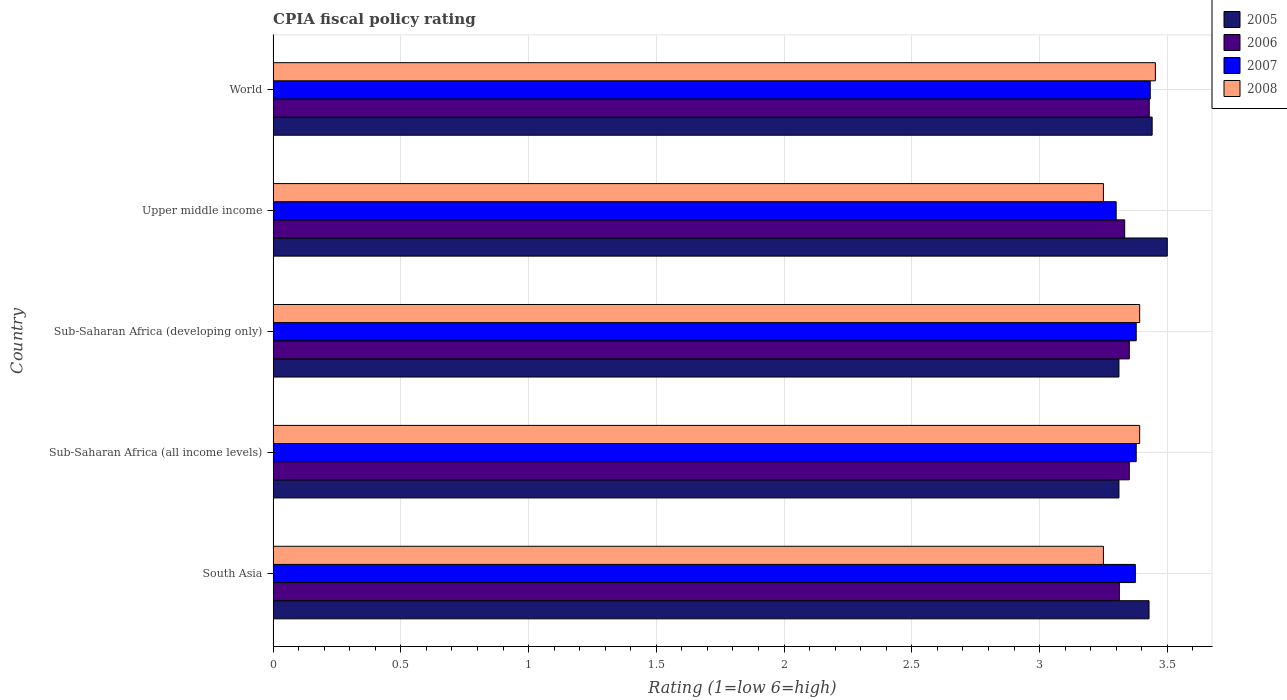How many bars are there on the 2nd tick from the top?
Provide a short and direct response. 4. What is the label of the 3rd group of bars from the top?
Keep it short and to the point. Sub-Saharan Africa (developing only). In how many cases, is the number of bars for a given country not equal to the number of legend labels?
Offer a terse response. 0. What is the CPIA rating in 2005 in Sub-Saharan Africa (developing only)?
Your response must be concise. 3.31. Across all countries, what is the maximum CPIA rating in 2006?
Provide a succinct answer. 3.43. Across all countries, what is the minimum CPIA rating in 2007?
Your answer should be compact. 3.3. What is the total CPIA rating in 2006 in the graph?
Keep it short and to the point. 16.78. What is the difference between the CPIA rating in 2007 in Sub-Saharan Africa (developing only) and that in Upper middle income?
Offer a terse response. 0.08. What is the difference between the CPIA rating in 2008 in Sub-Saharan Africa (developing only) and the CPIA rating in 2005 in World?
Your response must be concise. -0.05. What is the average CPIA rating in 2005 per country?
Your response must be concise. 3.4. What is the difference between the CPIA rating in 2005 and CPIA rating in 2008 in Sub-Saharan Africa (developing only)?
Ensure brevity in your answer.  -0.08. In how many countries, is the CPIA rating in 2008 greater than 0.4 ?
Ensure brevity in your answer.  5. What is the ratio of the CPIA rating in 2007 in Upper middle income to that in World?
Keep it short and to the point. 0.96. What is the difference between the highest and the second highest CPIA rating in 2005?
Make the answer very short. 0.06. What is the difference between the highest and the lowest CPIA rating in 2007?
Your response must be concise. 0.13. In how many countries, is the CPIA rating in 2005 greater than the average CPIA rating in 2005 taken over all countries?
Provide a succinct answer. 3. What does the 1st bar from the top in Upper middle income represents?
Your response must be concise. 2008. Is it the case that in every country, the sum of the CPIA rating in 2007 and CPIA rating in 2006 is greater than the CPIA rating in 2005?
Keep it short and to the point. Yes. Are all the bars in the graph horizontal?
Ensure brevity in your answer.  Yes. How many countries are there in the graph?
Offer a terse response. 5. Does the graph contain any zero values?
Keep it short and to the point. No. Does the graph contain grids?
Your answer should be compact. Yes. Where does the legend appear in the graph?
Your answer should be compact. Top right. How many legend labels are there?
Provide a succinct answer. 4. How are the legend labels stacked?
Give a very brief answer. Vertical. What is the title of the graph?
Provide a succinct answer. CPIA fiscal policy rating. What is the Rating (1=low 6=high) of 2005 in South Asia?
Provide a succinct answer. 3.43. What is the Rating (1=low 6=high) in 2006 in South Asia?
Ensure brevity in your answer.  3.31. What is the Rating (1=low 6=high) in 2007 in South Asia?
Offer a very short reply. 3.38. What is the Rating (1=low 6=high) of 2008 in South Asia?
Offer a very short reply. 3.25. What is the Rating (1=low 6=high) in 2005 in Sub-Saharan Africa (all income levels)?
Make the answer very short. 3.31. What is the Rating (1=low 6=high) of 2006 in Sub-Saharan Africa (all income levels)?
Your answer should be compact. 3.35. What is the Rating (1=low 6=high) of 2007 in Sub-Saharan Africa (all income levels)?
Offer a very short reply. 3.38. What is the Rating (1=low 6=high) of 2008 in Sub-Saharan Africa (all income levels)?
Your response must be concise. 3.39. What is the Rating (1=low 6=high) of 2005 in Sub-Saharan Africa (developing only)?
Offer a terse response. 3.31. What is the Rating (1=low 6=high) in 2006 in Sub-Saharan Africa (developing only)?
Keep it short and to the point. 3.35. What is the Rating (1=low 6=high) in 2007 in Sub-Saharan Africa (developing only)?
Offer a very short reply. 3.38. What is the Rating (1=low 6=high) of 2008 in Sub-Saharan Africa (developing only)?
Provide a short and direct response. 3.39. What is the Rating (1=low 6=high) of 2005 in Upper middle income?
Offer a very short reply. 3.5. What is the Rating (1=low 6=high) in 2006 in Upper middle income?
Give a very brief answer. 3.33. What is the Rating (1=low 6=high) of 2007 in Upper middle income?
Your answer should be compact. 3.3. What is the Rating (1=low 6=high) in 2005 in World?
Give a very brief answer. 3.44. What is the Rating (1=low 6=high) of 2006 in World?
Your answer should be very brief. 3.43. What is the Rating (1=low 6=high) in 2007 in World?
Your answer should be compact. 3.43. What is the Rating (1=low 6=high) in 2008 in World?
Give a very brief answer. 3.45. Across all countries, what is the maximum Rating (1=low 6=high) in 2005?
Give a very brief answer. 3.5. Across all countries, what is the maximum Rating (1=low 6=high) in 2006?
Your answer should be very brief. 3.43. Across all countries, what is the maximum Rating (1=low 6=high) of 2007?
Give a very brief answer. 3.43. Across all countries, what is the maximum Rating (1=low 6=high) in 2008?
Your answer should be very brief. 3.45. Across all countries, what is the minimum Rating (1=low 6=high) of 2005?
Offer a very short reply. 3.31. Across all countries, what is the minimum Rating (1=low 6=high) of 2006?
Keep it short and to the point. 3.31. What is the total Rating (1=low 6=high) of 2005 in the graph?
Your response must be concise. 16.99. What is the total Rating (1=low 6=high) in 2006 in the graph?
Give a very brief answer. 16.78. What is the total Rating (1=low 6=high) in 2007 in the graph?
Offer a very short reply. 16.87. What is the total Rating (1=low 6=high) in 2008 in the graph?
Ensure brevity in your answer.  16.74. What is the difference between the Rating (1=low 6=high) in 2005 in South Asia and that in Sub-Saharan Africa (all income levels)?
Provide a short and direct response. 0.12. What is the difference between the Rating (1=low 6=high) in 2006 in South Asia and that in Sub-Saharan Africa (all income levels)?
Provide a short and direct response. -0.04. What is the difference between the Rating (1=low 6=high) in 2007 in South Asia and that in Sub-Saharan Africa (all income levels)?
Keep it short and to the point. -0. What is the difference between the Rating (1=low 6=high) in 2008 in South Asia and that in Sub-Saharan Africa (all income levels)?
Ensure brevity in your answer.  -0.14. What is the difference between the Rating (1=low 6=high) in 2005 in South Asia and that in Sub-Saharan Africa (developing only)?
Offer a very short reply. 0.12. What is the difference between the Rating (1=low 6=high) of 2006 in South Asia and that in Sub-Saharan Africa (developing only)?
Ensure brevity in your answer.  -0.04. What is the difference between the Rating (1=low 6=high) in 2007 in South Asia and that in Sub-Saharan Africa (developing only)?
Provide a succinct answer. -0. What is the difference between the Rating (1=low 6=high) in 2008 in South Asia and that in Sub-Saharan Africa (developing only)?
Give a very brief answer. -0.14. What is the difference between the Rating (1=low 6=high) of 2005 in South Asia and that in Upper middle income?
Provide a short and direct response. -0.07. What is the difference between the Rating (1=low 6=high) of 2006 in South Asia and that in Upper middle income?
Offer a terse response. -0.02. What is the difference between the Rating (1=low 6=high) of 2007 in South Asia and that in Upper middle income?
Provide a short and direct response. 0.07. What is the difference between the Rating (1=low 6=high) in 2008 in South Asia and that in Upper middle income?
Ensure brevity in your answer.  0. What is the difference between the Rating (1=low 6=high) of 2005 in South Asia and that in World?
Offer a very short reply. -0.01. What is the difference between the Rating (1=low 6=high) in 2006 in South Asia and that in World?
Make the answer very short. -0.12. What is the difference between the Rating (1=low 6=high) in 2007 in South Asia and that in World?
Ensure brevity in your answer.  -0.06. What is the difference between the Rating (1=low 6=high) of 2008 in South Asia and that in World?
Make the answer very short. -0.2. What is the difference between the Rating (1=low 6=high) in 2005 in Sub-Saharan Africa (all income levels) and that in Upper middle income?
Your answer should be very brief. -0.19. What is the difference between the Rating (1=low 6=high) of 2006 in Sub-Saharan Africa (all income levels) and that in Upper middle income?
Make the answer very short. 0.02. What is the difference between the Rating (1=low 6=high) of 2007 in Sub-Saharan Africa (all income levels) and that in Upper middle income?
Your answer should be very brief. 0.08. What is the difference between the Rating (1=low 6=high) in 2008 in Sub-Saharan Africa (all income levels) and that in Upper middle income?
Make the answer very short. 0.14. What is the difference between the Rating (1=low 6=high) of 2005 in Sub-Saharan Africa (all income levels) and that in World?
Offer a very short reply. -0.13. What is the difference between the Rating (1=low 6=high) in 2006 in Sub-Saharan Africa (all income levels) and that in World?
Offer a terse response. -0.08. What is the difference between the Rating (1=low 6=high) in 2007 in Sub-Saharan Africa (all income levels) and that in World?
Your response must be concise. -0.06. What is the difference between the Rating (1=low 6=high) of 2008 in Sub-Saharan Africa (all income levels) and that in World?
Offer a very short reply. -0.06. What is the difference between the Rating (1=low 6=high) in 2005 in Sub-Saharan Africa (developing only) and that in Upper middle income?
Your answer should be compact. -0.19. What is the difference between the Rating (1=low 6=high) in 2006 in Sub-Saharan Africa (developing only) and that in Upper middle income?
Provide a short and direct response. 0.02. What is the difference between the Rating (1=low 6=high) of 2007 in Sub-Saharan Africa (developing only) and that in Upper middle income?
Offer a very short reply. 0.08. What is the difference between the Rating (1=low 6=high) in 2008 in Sub-Saharan Africa (developing only) and that in Upper middle income?
Keep it short and to the point. 0.14. What is the difference between the Rating (1=low 6=high) of 2005 in Sub-Saharan Africa (developing only) and that in World?
Ensure brevity in your answer.  -0.13. What is the difference between the Rating (1=low 6=high) in 2006 in Sub-Saharan Africa (developing only) and that in World?
Ensure brevity in your answer.  -0.08. What is the difference between the Rating (1=low 6=high) in 2007 in Sub-Saharan Africa (developing only) and that in World?
Keep it short and to the point. -0.06. What is the difference between the Rating (1=low 6=high) in 2008 in Sub-Saharan Africa (developing only) and that in World?
Your answer should be very brief. -0.06. What is the difference between the Rating (1=low 6=high) of 2005 in Upper middle income and that in World?
Provide a short and direct response. 0.06. What is the difference between the Rating (1=low 6=high) of 2006 in Upper middle income and that in World?
Offer a terse response. -0.1. What is the difference between the Rating (1=low 6=high) in 2007 in Upper middle income and that in World?
Your response must be concise. -0.13. What is the difference between the Rating (1=low 6=high) of 2008 in Upper middle income and that in World?
Give a very brief answer. -0.2. What is the difference between the Rating (1=low 6=high) in 2005 in South Asia and the Rating (1=low 6=high) in 2006 in Sub-Saharan Africa (all income levels)?
Your response must be concise. 0.08. What is the difference between the Rating (1=low 6=high) in 2005 in South Asia and the Rating (1=low 6=high) in 2007 in Sub-Saharan Africa (all income levels)?
Your answer should be very brief. 0.05. What is the difference between the Rating (1=low 6=high) in 2005 in South Asia and the Rating (1=low 6=high) in 2008 in Sub-Saharan Africa (all income levels)?
Your response must be concise. 0.04. What is the difference between the Rating (1=low 6=high) of 2006 in South Asia and the Rating (1=low 6=high) of 2007 in Sub-Saharan Africa (all income levels)?
Make the answer very short. -0.07. What is the difference between the Rating (1=low 6=high) of 2006 in South Asia and the Rating (1=low 6=high) of 2008 in Sub-Saharan Africa (all income levels)?
Your response must be concise. -0.08. What is the difference between the Rating (1=low 6=high) of 2007 in South Asia and the Rating (1=low 6=high) of 2008 in Sub-Saharan Africa (all income levels)?
Provide a succinct answer. -0.02. What is the difference between the Rating (1=low 6=high) in 2005 in South Asia and the Rating (1=low 6=high) in 2006 in Sub-Saharan Africa (developing only)?
Keep it short and to the point. 0.08. What is the difference between the Rating (1=low 6=high) of 2005 in South Asia and the Rating (1=low 6=high) of 2007 in Sub-Saharan Africa (developing only)?
Provide a short and direct response. 0.05. What is the difference between the Rating (1=low 6=high) in 2005 in South Asia and the Rating (1=low 6=high) in 2008 in Sub-Saharan Africa (developing only)?
Your response must be concise. 0.04. What is the difference between the Rating (1=low 6=high) of 2006 in South Asia and the Rating (1=low 6=high) of 2007 in Sub-Saharan Africa (developing only)?
Your answer should be very brief. -0.07. What is the difference between the Rating (1=low 6=high) in 2006 in South Asia and the Rating (1=low 6=high) in 2008 in Sub-Saharan Africa (developing only)?
Offer a very short reply. -0.08. What is the difference between the Rating (1=low 6=high) in 2007 in South Asia and the Rating (1=low 6=high) in 2008 in Sub-Saharan Africa (developing only)?
Offer a very short reply. -0.02. What is the difference between the Rating (1=low 6=high) in 2005 in South Asia and the Rating (1=low 6=high) in 2006 in Upper middle income?
Give a very brief answer. 0.1. What is the difference between the Rating (1=low 6=high) of 2005 in South Asia and the Rating (1=low 6=high) of 2007 in Upper middle income?
Offer a terse response. 0.13. What is the difference between the Rating (1=low 6=high) in 2005 in South Asia and the Rating (1=low 6=high) in 2008 in Upper middle income?
Provide a short and direct response. 0.18. What is the difference between the Rating (1=low 6=high) in 2006 in South Asia and the Rating (1=low 6=high) in 2007 in Upper middle income?
Offer a very short reply. 0.01. What is the difference between the Rating (1=low 6=high) in 2006 in South Asia and the Rating (1=low 6=high) in 2008 in Upper middle income?
Your answer should be very brief. 0.06. What is the difference between the Rating (1=low 6=high) in 2007 in South Asia and the Rating (1=low 6=high) in 2008 in Upper middle income?
Keep it short and to the point. 0.12. What is the difference between the Rating (1=low 6=high) in 2005 in South Asia and the Rating (1=low 6=high) in 2006 in World?
Your response must be concise. -0. What is the difference between the Rating (1=low 6=high) in 2005 in South Asia and the Rating (1=low 6=high) in 2007 in World?
Offer a very short reply. -0. What is the difference between the Rating (1=low 6=high) in 2005 in South Asia and the Rating (1=low 6=high) in 2008 in World?
Keep it short and to the point. -0.02. What is the difference between the Rating (1=low 6=high) of 2006 in South Asia and the Rating (1=low 6=high) of 2007 in World?
Provide a short and direct response. -0.12. What is the difference between the Rating (1=low 6=high) in 2006 in South Asia and the Rating (1=low 6=high) in 2008 in World?
Offer a terse response. -0.14. What is the difference between the Rating (1=low 6=high) in 2007 in South Asia and the Rating (1=low 6=high) in 2008 in World?
Offer a terse response. -0.08. What is the difference between the Rating (1=low 6=high) of 2005 in Sub-Saharan Africa (all income levels) and the Rating (1=low 6=high) of 2006 in Sub-Saharan Africa (developing only)?
Ensure brevity in your answer.  -0.04. What is the difference between the Rating (1=low 6=high) in 2005 in Sub-Saharan Africa (all income levels) and the Rating (1=low 6=high) in 2007 in Sub-Saharan Africa (developing only)?
Provide a short and direct response. -0.07. What is the difference between the Rating (1=low 6=high) of 2005 in Sub-Saharan Africa (all income levels) and the Rating (1=low 6=high) of 2008 in Sub-Saharan Africa (developing only)?
Offer a very short reply. -0.08. What is the difference between the Rating (1=low 6=high) of 2006 in Sub-Saharan Africa (all income levels) and the Rating (1=low 6=high) of 2007 in Sub-Saharan Africa (developing only)?
Offer a terse response. -0.03. What is the difference between the Rating (1=low 6=high) in 2006 in Sub-Saharan Africa (all income levels) and the Rating (1=low 6=high) in 2008 in Sub-Saharan Africa (developing only)?
Your response must be concise. -0.04. What is the difference between the Rating (1=low 6=high) in 2007 in Sub-Saharan Africa (all income levels) and the Rating (1=low 6=high) in 2008 in Sub-Saharan Africa (developing only)?
Keep it short and to the point. -0.01. What is the difference between the Rating (1=low 6=high) of 2005 in Sub-Saharan Africa (all income levels) and the Rating (1=low 6=high) of 2006 in Upper middle income?
Offer a terse response. -0.02. What is the difference between the Rating (1=low 6=high) in 2005 in Sub-Saharan Africa (all income levels) and the Rating (1=low 6=high) in 2007 in Upper middle income?
Make the answer very short. 0.01. What is the difference between the Rating (1=low 6=high) in 2005 in Sub-Saharan Africa (all income levels) and the Rating (1=low 6=high) in 2008 in Upper middle income?
Provide a short and direct response. 0.06. What is the difference between the Rating (1=low 6=high) in 2006 in Sub-Saharan Africa (all income levels) and the Rating (1=low 6=high) in 2007 in Upper middle income?
Keep it short and to the point. 0.05. What is the difference between the Rating (1=low 6=high) of 2006 in Sub-Saharan Africa (all income levels) and the Rating (1=low 6=high) of 2008 in Upper middle income?
Your answer should be compact. 0.1. What is the difference between the Rating (1=low 6=high) of 2007 in Sub-Saharan Africa (all income levels) and the Rating (1=low 6=high) of 2008 in Upper middle income?
Keep it short and to the point. 0.13. What is the difference between the Rating (1=low 6=high) in 2005 in Sub-Saharan Africa (all income levels) and the Rating (1=low 6=high) in 2006 in World?
Give a very brief answer. -0.12. What is the difference between the Rating (1=low 6=high) of 2005 in Sub-Saharan Africa (all income levels) and the Rating (1=low 6=high) of 2007 in World?
Ensure brevity in your answer.  -0.12. What is the difference between the Rating (1=low 6=high) of 2005 in Sub-Saharan Africa (all income levels) and the Rating (1=low 6=high) of 2008 in World?
Offer a very short reply. -0.14. What is the difference between the Rating (1=low 6=high) in 2006 in Sub-Saharan Africa (all income levels) and the Rating (1=low 6=high) in 2007 in World?
Make the answer very short. -0.08. What is the difference between the Rating (1=low 6=high) in 2006 in Sub-Saharan Africa (all income levels) and the Rating (1=low 6=high) in 2008 in World?
Provide a short and direct response. -0.1. What is the difference between the Rating (1=low 6=high) of 2007 in Sub-Saharan Africa (all income levels) and the Rating (1=low 6=high) of 2008 in World?
Provide a short and direct response. -0.07. What is the difference between the Rating (1=low 6=high) of 2005 in Sub-Saharan Africa (developing only) and the Rating (1=low 6=high) of 2006 in Upper middle income?
Keep it short and to the point. -0.02. What is the difference between the Rating (1=low 6=high) in 2005 in Sub-Saharan Africa (developing only) and the Rating (1=low 6=high) in 2007 in Upper middle income?
Ensure brevity in your answer.  0.01. What is the difference between the Rating (1=low 6=high) in 2005 in Sub-Saharan Africa (developing only) and the Rating (1=low 6=high) in 2008 in Upper middle income?
Offer a very short reply. 0.06. What is the difference between the Rating (1=low 6=high) of 2006 in Sub-Saharan Africa (developing only) and the Rating (1=low 6=high) of 2007 in Upper middle income?
Offer a very short reply. 0.05. What is the difference between the Rating (1=low 6=high) in 2006 in Sub-Saharan Africa (developing only) and the Rating (1=low 6=high) in 2008 in Upper middle income?
Offer a very short reply. 0.1. What is the difference between the Rating (1=low 6=high) in 2007 in Sub-Saharan Africa (developing only) and the Rating (1=low 6=high) in 2008 in Upper middle income?
Your answer should be very brief. 0.13. What is the difference between the Rating (1=low 6=high) in 2005 in Sub-Saharan Africa (developing only) and the Rating (1=low 6=high) in 2006 in World?
Give a very brief answer. -0.12. What is the difference between the Rating (1=low 6=high) of 2005 in Sub-Saharan Africa (developing only) and the Rating (1=low 6=high) of 2007 in World?
Your answer should be very brief. -0.12. What is the difference between the Rating (1=low 6=high) in 2005 in Sub-Saharan Africa (developing only) and the Rating (1=low 6=high) in 2008 in World?
Provide a short and direct response. -0.14. What is the difference between the Rating (1=low 6=high) in 2006 in Sub-Saharan Africa (developing only) and the Rating (1=low 6=high) in 2007 in World?
Offer a terse response. -0.08. What is the difference between the Rating (1=low 6=high) of 2006 in Sub-Saharan Africa (developing only) and the Rating (1=low 6=high) of 2008 in World?
Provide a short and direct response. -0.1. What is the difference between the Rating (1=low 6=high) in 2007 in Sub-Saharan Africa (developing only) and the Rating (1=low 6=high) in 2008 in World?
Provide a succinct answer. -0.07. What is the difference between the Rating (1=low 6=high) of 2005 in Upper middle income and the Rating (1=low 6=high) of 2006 in World?
Provide a short and direct response. 0.07. What is the difference between the Rating (1=low 6=high) of 2005 in Upper middle income and the Rating (1=low 6=high) of 2007 in World?
Your response must be concise. 0.07. What is the difference between the Rating (1=low 6=high) in 2005 in Upper middle income and the Rating (1=low 6=high) in 2008 in World?
Provide a succinct answer. 0.05. What is the difference between the Rating (1=low 6=high) of 2006 in Upper middle income and the Rating (1=low 6=high) of 2007 in World?
Your response must be concise. -0.1. What is the difference between the Rating (1=low 6=high) of 2006 in Upper middle income and the Rating (1=low 6=high) of 2008 in World?
Offer a terse response. -0.12. What is the difference between the Rating (1=low 6=high) in 2007 in Upper middle income and the Rating (1=low 6=high) in 2008 in World?
Offer a very short reply. -0.15. What is the average Rating (1=low 6=high) of 2005 per country?
Offer a terse response. 3.4. What is the average Rating (1=low 6=high) of 2006 per country?
Give a very brief answer. 3.36. What is the average Rating (1=low 6=high) of 2007 per country?
Offer a very short reply. 3.37. What is the average Rating (1=low 6=high) of 2008 per country?
Ensure brevity in your answer.  3.35. What is the difference between the Rating (1=low 6=high) in 2005 and Rating (1=low 6=high) in 2006 in South Asia?
Give a very brief answer. 0.12. What is the difference between the Rating (1=low 6=high) of 2005 and Rating (1=low 6=high) of 2007 in South Asia?
Provide a short and direct response. 0.05. What is the difference between the Rating (1=low 6=high) of 2005 and Rating (1=low 6=high) of 2008 in South Asia?
Your response must be concise. 0.18. What is the difference between the Rating (1=low 6=high) in 2006 and Rating (1=low 6=high) in 2007 in South Asia?
Your response must be concise. -0.06. What is the difference between the Rating (1=low 6=high) in 2006 and Rating (1=low 6=high) in 2008 in South Asia?
Give a very brief answer. 0.06. What is the difference between the Rating (1=low 6=high) of 2007 and Rating (1=low 6=high) of 2008 in South Asia?
Your answer should be very brief. 0.12. What is the difference between the Rating (1=low 6=high) of 2005 and Rating (1=low 6=high) of 2006 in Sub-Saharan Africa (all income levels)?
Give a very brief answer. -0.04. What is the difference between the Rating (1=low 6=high) in 2005 and Rating (1=low 6=high) in 2007 in Sub-Saharan Africa (all income levels)?
Offer a terse response. -0.07. What is the difference between the Rating (1=low 6=high) in 2005 and Rating (1=low 6=high) in 2008 in Sub-Saharan Africa (all income levels)?
Offer a very short reply. -0.08. What is the difference between the Rating (1=low 6=high) of 2006 and Rating (1=low 6=high) of 2007 in Sub-Saharan Africa (all income levels)?
Provide a succinct answer. -0.03. What is the difference between the Rating (1=low 6=high) of 2006 and Rating (1=low 6=high) of 2008 in Sub-Saharan Africa (all income levels)?
Give a very brief answer. -0.04. What is the difference between the Rating (1=low 6=high) in 2007 and Rating (1=low 6=high) in 2008 in Sub-Saharan Africa (all income levels)?
Provide a succinct answer. -0.01. What is the difference between the Rating (1=low 6=high) in 2005 and Rating (1=low 6=high) in 2006 in Sub-Saharan Africa (developing only)?
Your answer should be compact. -0.04. What is the difference between the Rating (1=low 6=high) of 2005 and Rating (1=low 6=high) of 2007 in Sub-Saharan Africa (developing only)?
Give a very brief answer. -0.07. What is the difference between the Rating (1=low 6=high) of 2005 and Rating (1=low 6=high) of 2008 in Sub-Saharan Africa (developing only)?
Offer a terse response. -0.08. What is the difference between the Rating (1=low 6=high) in 2006 and Rating (1=low 6=high) in 2007 in Sub-Saharan Africa (developing only)?
Provide a short and direct response. -0.03. What is the difference between the Rating (1=low 6=high) in 2006 and Rating (1=low 6=high) in 2008 in Sub-Saharan Africa (developing only)?
Make the answer very short. -0.04. What is the difference between the Rating (1=low 6=high) of 2007 and Rating (1=low 6=high) of 2008 in Sub-Saharan Africa (developing only)?
Offer a very short reply. -0.01. What is the difference between the Rating (1=low 6=high) in 2005 and Rating (1=low 6=high) in 2008 in Upper middle income?
Keep it short and to the point. 0.25. What is the difference between the Rating (1=low 6=high) in 2006 and Rating (1=low 6=high) in 2008 in Upper middle income?
Make the answer very short. 0.08. What is the difference between the Rating (1=low 6=high) of 2007 and Rating (1=low 6=high) of 2008 in Upper middle income?
Your answer should be compact. 0.05. What is the difference between the Rating (1=low 6=high) of 2005 and Rating (1=low 6=high) of 2006 in World?
Offer a terse response. 0.01. What is the difference between the Rating (1=low 6=high) of 2005 and Rating (1=low 6=high) of 2007 in World?
Ensure brevity in your answer.  0.01. What is the difference between the Rating (1=low 6=high) in 2005 and Rating (1=low 6=high) in 2008 in World?
Ensure brevity in your answer.  -0.01. What is the difference between the Rating (1=low 6=high) of 2006 and Rating (1=low 6=high) of 2007 in World?
Make the answer very short. -0. What is the difference between the Rating (1=low 6=high) of 2006 and Rating (1=low 6=high) of 2008 in World?
Keep it short and to the point. -0.02. What is the difference between the Rating (1=low 6=high) of 2007 and Rating (1=low 6=high) of 2008 in World?
Provide a succinct answer. -0.02. What is the ratio of the Rating (1=low 6=high) of 2005 in South Asia to that in Sub-Saharan Africa (all income levels)?
Your answer should be very brief. 1.04. What is the ratio of the Rating (1=low 6=high) of 2006 in South Asia to that in Sub-Saharan Africa (all income levels)?
Offer a terse response. 0.99. What is the ratio of the Rating (1=low 6=high) in 2007 in South Asia to that in Sub-Saharan Africa (all income levels)?
Give a very brief answer. 1. What is the ratio of the Rating (1=low 6=high) in 2008 in South Asia to that in Sub-Saharan Africa (all income levels)?
Give a very brief answer. 0.96. What is the ratio of the Rating (1=low 6=high) of 2005 in South Asia to that in Sub-Saharan Africa (developing only)?
Your answer should be very brief. 1.04. What is the ratio of the Rating (1=low 6=high) of 2006 in South Asia to that in Sub-Saharan Africa (developing only)?
Offer a terse response. 0.99. What is the ratio of the Rating (1=low 6=high) in 2007 in South Asia to that in Sub-Saharan Africa (developing only)?
Your answer should be very brief. 1. What is the ratio of the Rating (1=low 6=high) of 2008 in South Asia to that in Sub-Saharan Africa (developing only)?
Your answer should be compact. 0.96. What is the ratio of the Rating (1=low 6=high) of 2005 in South Asia to that in Upper middle income?
Keep it short and to the point. 0.98. What is the ratio of the Rating (1=low 6=high) of 2007 in South Asia to that in Upper middle income?
Your answer should be very brief. 1.02. What is the ratio of the Rating (1=low 6=high) in 2006 in South Asia to that in World?
Offer a terse response. 0.97. What is the ratio of the Rating (1=low 6=high) in 2007 in South Asia to that in World?
Ensure brevity in your answer.  0.98. What is the ratio of the Rating (1=low 6=high) in 2008 in South Asia to that in World?
Ensure brevity in your answer.  0.94. What is the ratio of the Rating (1=low 6=high) of 2005 in Sub-Saharan Africa (all income levels) to that in Sub-Saharan Africa (developing only)?
Your answer should be compact. 1. What is the ratio of the Rating (1=low 6=high) of 2006 in Sub-Saharan Africa (all income levels) to that in Sub-Saharan Africa (developing only)?
Your answer should be compact. 1. What is the ratio of the Rating (1=low 6=high) in 2007 in Sub-Saharan Africa (all income levels) to that in Sub-Saharan Africa (developing only)?
Your response must be concise. 1. What is the ratio of the Rating (1=low 6=high) in 2005 in Sub-Saharan Africa (all income levels) to that in Upper middle income?
Offer a very short reply. 0.95. What is the ratio of the Rating (1=low 6=high) in 2006 in Sub-Saharan Africa (all income levels) to that in Upper middle income?
Provide a succinct answer. 1.01. What is the ratio of the Rating (1=low 6=high) of 2007 in Sub-Saharan Africa (all income levels) to that in Upper middle income?
Offer a very short reply. 1.02. What is the ratio of the Rating (1=low 6=high) in 2008 in Sub-Saharan Africa (all income levels) to that in Upper middle income?
Your answer should be very brief. 1.04. What is the ratio of the Rating (1=low 6=high) in 2005 in Sub-Saharan Africa (all income levels) to that in World?
Offer a terse response. 0.96. What is the ratio of the Rating (1=low 6=high) in 2006 in Sub-Saharan Africa (all income levels) to that in World?
Your answer should be very brief. 0.98. What is the ratio of the Rating (1=low 6=high) in 2007 in Sub-Saharan Africa (all income levels) to that in World?
Provide a succinct answer. 0.98. What is the ratio of the Rating (1=low 6=high) of 2008 in Sub-Saharan Africa (all income levels) to that in World?
Give a very brief answer. 0.98. What is the ratio of the Rating (1=low 6=high) in 2005 in Sub-Saharan Africa (developing only) to that in Upper middle income?
Offer a terse response. 0.95. What is the ratio of the Rating (1=low 6=high) of 2006 in Sub-Saharan Africa (developing only) to that in Upper middle income?
Provide a short and direct response. 1.01. What is the ratio of the Rating (1=low 6=high) in 2007 in Sub-Saharan Africa (developing only) to that in Upper middle income?
Give a very brief answer. 1.02. What is the ratio of the Rating (1=low 6=high) of 2008 in Sub-Saharan Africa (developing only) to that in Upper middle income?
Provide a short and direct response. 1.04. What is the ratio of the Rating (1=low 6=high) in 2005 in Sub-Saharan Africa (developing only) to that in World?
Give a very brief answer. 0.96. What is the ratio of the Rating (1=low 6=high) in 2006 in Sub-Saharan Africa (developing only) to that in World?
Offer a very short reply. 0.98. What is the ratio of the Rating (1=low 6=high) in 2007 in Sub-Saharan Africa (developing only) to that in World?
Your response must be concise. 0.98. What is the ratio of the Rating (1=low 6=high) in 2008 in Sub-Saharan Africa (developing only) to that in World?
Your answer should be very brief. 0.98. What is the ratio of the Rating (1=low 6=high) of 2005 in Upper middle income to that in World?
Make the answer very short. 1.02. What is the ratio of the Rating (1=low 6=high) in 2007 in Upper middle income to that in World?
Offer a terse response. 0.96. What is the ratio of the Rating (1=low 6=high) in 2008 in Upper middle income to that in World?
Offer a terse response. 0.94. What is the difference between the highest and the second highest Rating (1=low 6=high) of 2005?
Make the answer very short. 0.06. What is the difference between the highest and the second highest Rating (1=low 6=high) in 2006?
Offer a very short reply. 0.08. What is the difference between the highest and the second highest Rating (1=low 6=high) of 2007?
Give a very brief answer. 0.06. What is the difference between the highest and the second highest Rating (1=low 6=high) of 2008?
Keep it short and to the point. 0.06. What is the difference between the highest and the lowest Rating (1=low 6=high) in 2005?
Offer a terse response. 0.19. What is the difference between the highest and the lowest Rating (1=low 6=high) of 2006?
Give a very brief answer. 0.12. What is the difference between the highest and the lowest Rating (1=low 6=high) of 2007?
Make the answer very short. 0.13. What is the difference between the highest and the lowest Rating (1=low 6=high) in 2008?
Your response must be concise. 0.2. 